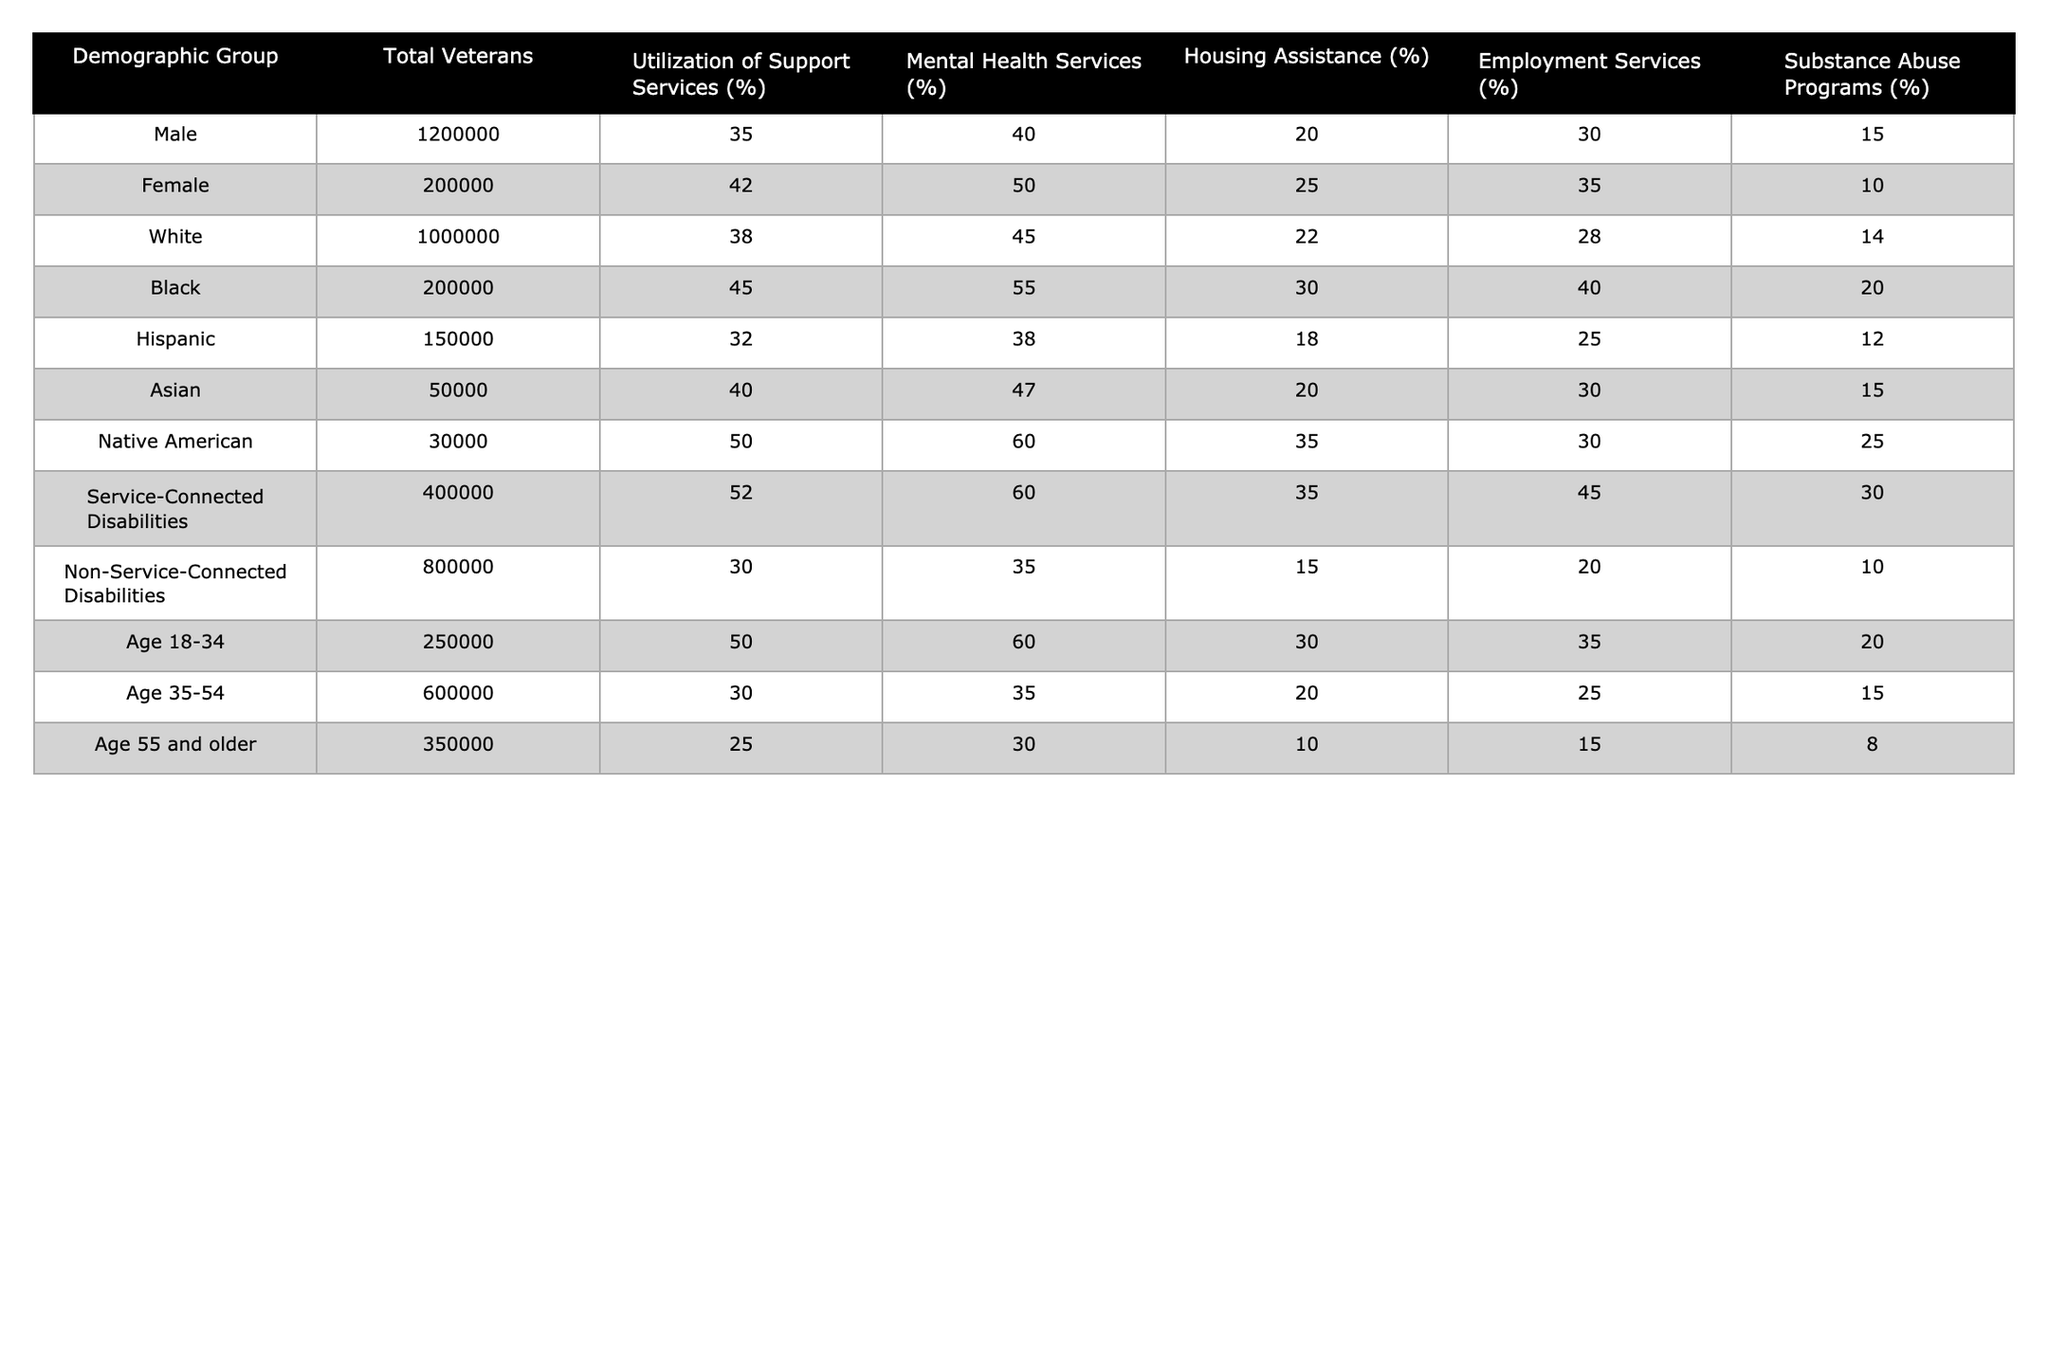What percentage of female veterans utilized mental health services? The table shows that 50% of female veterans utilized mental health services.
Answer: 50% Which demographic group has the highest utilization rate for housing assistance? According to the table, Native American veterans have the highest utilization rate for housing assistance at 35%.
Answer: 35% Are more Black or Hispanic veterans utilizing employment services? The table indicates that 40% of Black veterans utilize employment services, while only 25% of Hispanic veterans do. Therefore, more Black veterans are utilizing these services.
Answer: Yes What is the difference in utilization of substance abuse programs between veterans with service-connected disabilities and those without? The table states that the utilization of substance abuse programs is 30% for veterans with service-connected disabilities and 10% for those without. The difference is 30% - 10% = 20%.
Answer: 20% What is the average percentage of support service utilization for veterans aged 35-54? The percentage of support service utilization for veterans aged 35-54 is 30%. This can be found directly in the table. Therefore, the average is also 30%.
Answer: 30% What percentage of total veterans utilize mental health services in the Hispanic demographic? From the table, 38% of Hispanic veterans utilized mental health services.
Answer: 38% Which age group has the highest percentage of utilization for housing assistance? The age group 18-34, with a utilization rate of 30% for housing assistance, is the highest compared to the other age groups.
Answer: Age 18-34 Are there more female veterans or veterans with service-connected disabilities utilizing support services? Female veterans utilize support services at a rate of 42%, while veterans with service-connected disabilities utilize them at 52%. So, there are more veterans with service-connected disabilities utilizing these services.
Answer: Yes If we sum the percentages of employment services for all demographic groups, what will be the result? The sum is 30% (Male) + 35% (Female) + 28% (White) + 40% (Black) + 25% (Hispanic) + 30% (Asian) + 45% (Native American) + 20% (Service-Connected Disabilities) + 20% (Non-Service-Connected Disabilities) + 35% (Age 18-34) + 25% (Age 35-54) + 15% (Age 55 and older) =  408%.
Answer: 408% What can be inferred about the relationship between age and support service utilization among veterans? The data shows that utilization of support services generally decreases with age; the younger demographic (ages 18-34) has a higher percentage (50%) than older demographics (35-54: 30%, 55 and older: 25%).
Answer: Decreases with age 